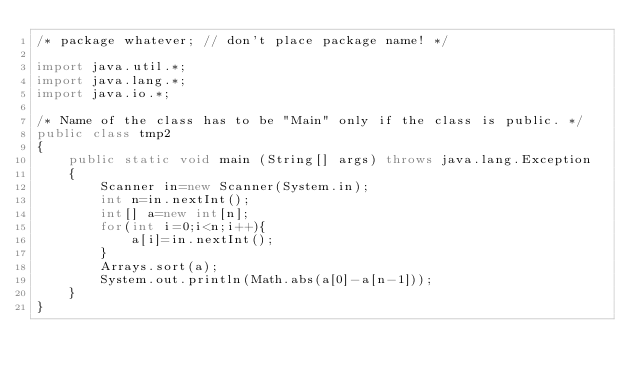Convert code to text. <code><loc_0><loc_0><loc_500><loc_500><_Java_>/* package whatever; // don't place package name! */

import java.util.*;
import java.lang.*;
import java.io.*;

/* Name of the class has to be "Main" only if the class is public. */
public class tmp2
{
	public static void main (String[] args) throws java.lang.Exception
	{
		Scanner in=new Scanner(System.in);
		int n=in.nextInt();
		int[] a=new int[n];
		for(int i=0;i<n;i++){
			a[i]=in.nextInt();
		}
		Arrays.sort(a);
		System.out.println(Math.abs(a[0]-a[n-1]));
	}
}</code> 